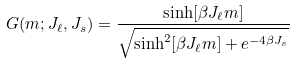<formula> <loc_0><loc_0><loc_500><loc_500>G ( m ; J _ { \ell } , J _ { s } ) = \frac { \sinh [ \beta J _ { \ell } m ] } { \sqrt { \sinh ^ { 2 } [ \beta J _ { \ell } m ] + e ^ { - 4 \beta J _ { s } } } }</formula> 